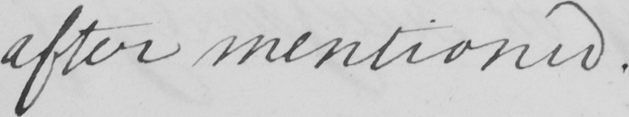What text is written in this handwritten line? after mentioned . 